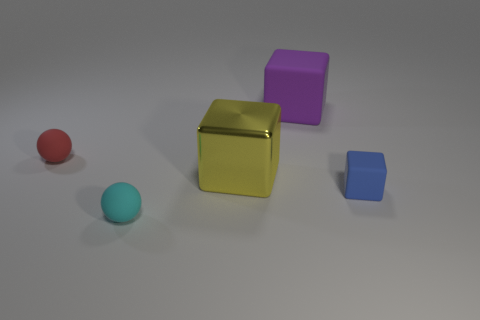Add 3 small cyan matte objects. How many objects exist? 8 Subtract all blocks. How many objects are left? 2 Add 1 tiny red balls. How many tiny red balls are left? 2 Add 3 big purple objects. How many big purple objects exist? 4 Subtract 0 purple cylinders. How many objects are left? 5 Subtract all purple matte objects. Subtract all matte blocks. How many objects are left? 2 